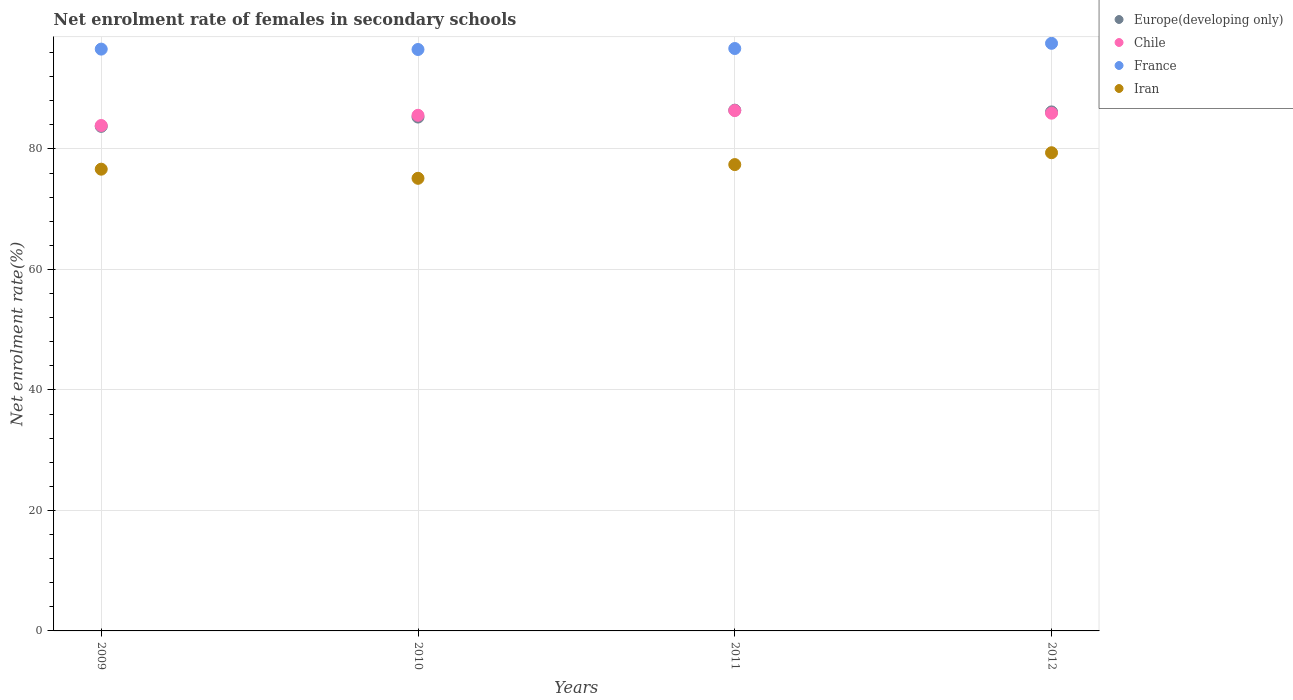What is the net enrolment rate of females in secondary schools in Iran in 2011?
Give a very brief answer. 77.4. Across all years, what is the maximum net enrolment rate of females in secondary schools in Iran?
Provide a short and direct response. 79.37. Across all years, what is the minimum net enrolment rate of females in secondary schools in Iran?
Your response must be concise. 75.12. In which year was the net enrolment rate of females in secondary schools in Iran minimum?
Provide a succinct answer. 2010. What is the total net enrolment rate of females in secondary schools in Iran in the graph?
Your answer should be very brief. 308.53. What is the difference between the net enrolment rate of females in secondary schools in Chile in 2011 and that in 2012?
Keep it short and to the point. 0.44. What is the difference between the net enrolment rate of females in secondary schools in Iran in 2012 and the net enrolment rate of females in secondary schools in Chile in 2009?
Offer a very short reply. -4.52. What is the average net enrolment rate of females in secondary schools in Chile per year?
Your answer should be very brief. 85.44. In the year 2012, what is the difference between the net enrolment rate of females in secondary schools in Chile and net enrolment rate of females in secondary schools in France?
Provide a succinct answer. -11.6. What is the ratio of the net enrolment rate of females in secondary schools in Chile in 2010 to that in 2012?
Make the answer very short. 1. What is the difference between the highest and the second highest net enrolment rate of females in secondary schools in France?
Provide a succinct answer. 0.86. What is the difference between the highest and the lowest net enrolment rate of females in secondary schools in France?
Ensure brevity in your answer.  1.02. Is the sum of the net enrolment rate of females in secondary schools in Chile in 2009 and 2012 greater than the maximum net enrolment rate of females in secondary schools in France across all years?
Offer a very short reply. Yes. Is it the case that in every year, the sum of the net enrolment rate of females in secondary schools in France and net enrolment rate of females in secondary schools in Chile  is greater than the net enrolment rate of females in secondary schools in Iran?
Keep it short and to the point. Yes. Is the net enrolment rate of females in secondary schools in Chile strictly greater than the net enrolment rate of females in secondary schools in France over the years?
Offer a terse response. No. Is the net enrolment rate of females in secondary schools in France strictly less than the net enrolment rate of females in secondary schools in Iran over the years?
Your answer should be compact. No. What is the difference between two consecutive major ticks on the Y-axis?
Your answer should be very brief. 20. Are the values on the major ticks of Y-axis written in scientific E-notation?
Give a very brief answer. No. Does the graph contain any zero values?
Provide a short and direct response. No. How many legend labels are there?
Provide a succinct answer. 4. How are the legend labels stacked?
Offer a very short reply. Vertical. What is the title of the graph?
Keep it short and to the point. Net enrolment rate of females in secondary schools. Does "Latvia" appear as one of the legend labels in the graph?
Provide a short and direct response. No. What is the label or title of the X-axis?
Offer a very short reply. Years. What is the label or title of the Y-axis?
Your answer should be compact. Net enrolment rate(%). What is the Net enrolment rate(%) in Europe(developing only) in 2009?
Provide a succinct answer. 83.75. What is the Net enrolment rate(%) in Chile in 2009?
Offer a terse response. 83.89. What is the Net enrolment rate(%) of France in 2009?
Provide a short and direct response. 96.57. What is the Net enrolment rate(%) in Iran in 2009?
Provide a succinct answer. 76.64. What is the Net enrolment rate(%) in Europe(developing only) in 2010?
Give a very brief answer. 85.29. What is the Net enrolment rate(%) in Chile in 2010?
Your answer should be compact. 85.58. What is the Net enrolment rate(%) of France in 2010?
Ensure brevity in your answer.  96.51. What is the Net enrolment rate(%) in Iran in 2010?
Offer a very short reply. 75.12. What is the Net enrolment rate(%) of Europe(developing only) in 2011?
Your answer should be compact. 86.43. What is the Net enrolment rate(%) of Chile in 2011?
Your answer should be very brief. 86.37. What is the Net enrolment rate(%) of France in 2011?
Offer a very short reply. 96.67. What is the Net enrolment rate(%) of Iran in 2011?
Give a very brief answer. 77.4. What is the Net enrolment rate(%) in Europe(developing only) in 2012?
Make the answer very short. 86.14. What is the Net enrolment rate(%) of Chile in 2012?
Keep it short and to the point. 85.93. What is the Net enrolment rate(%) in France in 2012?
Your response must be concise. 97.53. What is the Net enrolment rate(%) of Iran in 2012?
Provide a succinct answer. 79.37. Across all years, what is the maximum Net enrolment rate(%) in Europe(developing only)?
Offer a terse response. 86.43. Across all years, what is the maximum Net enrolment rate(%) of Chile?
Your response must be concise. 86.37. Across all years, what is the maximum Net enrolment rate(%) of France?
Your answer should be very brief. 97.53. Across all years, what is the maximum Net enrolment rate(%) of Iran?
Make the answer very short. 79.37. Across all years, what is the minimum Net enrolment rate(%) of Europe(developing only)?
Ensure brevity in your answer.  83.75. Across all years, what is the minimum Net enrolment rate(%) of Chile?
Ensure brevity in your answer.  83.89. Across all years, what is the minimum Net enrolment rate(%) in France?
Make the answer very short. 96.51. Across all years, what is the minimum Net enrolment rate(%) in Iran?
Give a very brief answer. 75.12. What is the total Net enrolment rate(%) in Europe(developing only) in the graph?
Keep it short and to the point. 341.61. What is the total Net enrolment rate(%) of Chile in the graph?
Your answer should be very brief. 341.77. What is the total Net enrolment rate(%) in France in the graph?
Give a very brief answer. 387.27. What is the total Net enrolment rate(%) of Iran in the graph?
Make the answer very short. 308.53. What is the difference between the Net enrolment rate(%) in Europe(developing only) in 2009 and that in 2010?
Keep it short and to the point. -1.54. What is the difference between the Net enrolment rate(%) in Chile in 2009 and that in 2010?
Your answer should be compact. -1.69. What is the difference between the Net enrolment rate(%) in France in 2009 and that in 2010?
Provide a short and direct response. 0.06. What is the difference between the Net enrolment rate(%) in Iran in 2009 and that in 2010?
Provide a succinct answer. 1.51. What is the difference between the Net enrolment rate(%) of Europe(developing only) in 2009 and that in 2011?
Provide a succinct answer. -2.69. What is the difference between the Net enrolment rate(%) in Chile in 2009 and that in 2011?
Offer a very short reply. -2.48. What is the difference between the Net enrolment rate(%) in France in 2009 and that in 2011?
Your answer should be very brief. -0.1. What is the difference between the Net enrolment rate(%) in Iran in 2009 and that in 2011?
Give a very brief answer. -0.76. What is the difference between the Net enrolment rate(%) of Europe(developing only) in 2009 and that in 2012?
Your response must be concise. -2.4. What is the difference between the Net enrolment rate(%) in Chile in 2009 and that in 2012?
Keep it short and to the point. -2.04. What is the difference between the Net enrolment rate(%) of France in 2009 and that in 2012?
Ensure brevity in your answer.  -0.96. What is the difference between the Net enrolment rate(%) in Iran in 2009 and that in 2012?
Offer a terse response. -2.73. What is the difference between the Net enrolment rate(%) in Europe(developing only) in 2010 and that in 2011?
Your response must be concise. -1.14. What is the difference between the Net enrolment rate(%) in Chile in 2010 and that in 2011?
Ensure brevity in your answer.  -0.78. What is the difference between the Net enrolment rate(%) of France in 2010 and that in 2011?
Provide a succinct answer. -0.16. What is the difference between the Net enrolment rate(%) of Iran in 2010 and that in 2011?
Your answer should be very brief. -2.28. What is the difference between the Net enrolment rate(%) in Europe(developing only) in 2010 and that in 2012?
Your answer should be very brief. -0.85. What is the difference between the Net enrolment rate(%) of Chile in 2010 and that in 2012?
Ensure brevity in your answer.  -0.35. What is the difference between the Net enrolment rate(%) of France in 2010 and that in 2012?
Provide a succinct answer. -1.02. What is the difference between the Net enrolment rate(%) in Iran in 2010 and that in 2012?
Your answer should be compact. -4.24. What is the difference between the Net enrolment rate(%) of Europe(developing only) in 2011 and that in 2012?
Offer a terse response. 0.29. What is the difference between the Net enrolment rate(%) in Chile in 2011 and that in 2012?
Offer a very short reply. 0.44. What is the difference between the Net enrolment rate(%) in France in 2011 and that in 2012?
Your response must be concise. -0.86. What is the difference between the Net enrolment rate(%) of Iran in 2011 and that in 2012?
Your answer should be compact. -1.97. What is the difference between the Net enrolment rate(%) in Europe(developing only) in 2009 and the Net enrolment rate(%) in Chile in 2010?
Make the answer very short. -1.84. What is the difference between the Net enrolment rate(%) in Europe(developing only) in 2009 and the Net enrolment rate(%) in France in 2010?
Your response must be concise. -12.76. What is the difference between the Net enrolment rate(%) in Europe(developing only) in 2009 and the Net enrolment rate(%) in Iran in 2010?
Provide a succinct answer. 8.62. What is the difference between the Net enrolment rate(%) of Chile in 2009 and the Net enrolment rate(%) of France in 2010?
Give a very brief answer. -12.61. What is the difference between the Net enrolment rate(%) of Chile in 2009 and the Net enrolment rate(%) of Iran in 2010?
Your answer should be compact. 8.77. What is the difference between the Net enrolment rate(%) in France in 2009 and the Net enrolment rate(%) in Iran in 2010?
Your answer should be very brief. 21.44. What is the difference between the Net enrolment rate(%) in Europe(developing only) in 2009 and the Net enrolment rate(%) in Chile in 2011?
Give a very brief answer. -2.62. What is the difference between the Net enrolment rate(%) of Europe(developing only) in 2009 and the Net enrolment rate(%) of France in 2011?
Offer a terse response. -12.92. What is the difference between the Net enrolment rate(%) of Europe(developing only) in 2009 and the Net enrolment rate(%) of Iran in 2011?
Your answer should be very brief. 6.34. What is the difference between the Net enrolment rate(%) of Chile in 2009 and the Net enrolment rate(%) of France in 2011?
Ensure brevity in your answer.  -12.78. What is the difference between the Net enrolment rate(%) of Chile in 2009 and the Net enrolment rate(%) of Iran in 2011?
Provide a succinct answer. 6.49. What is the difference between the Net enrolment rate(%) in France in 2009 and the Net enrolment rate(%) in Iran in 2011?
Give a very brief answer. 19.17. What is the difference between the Net enrolment rate(%) of Europe(developing only) in 2009 and the Net enrolment rate(%) of Chile in 2012?
Provide a succinct answer. -2.18. What is the difference between the Net enrolment rate(%) in Europe(developing only) in 2009 and the Net enrolment rate(%) in France in 2012?
Give a very brief answer. -13.78. What is the difference between the Net enrolment rate(%) in Europe(developing only) in 2009 and the Net enrolment rate(%) in Iran in 2012?
Keep it short and to the point. 4.38. What is the difference between the Net enrolment rate(%) of Chile in 2009 and the Net enrolment rate(%) of France in 2012?
Your answer should be compact. -13.64. What is the difference between the Net enrolment rate(%) of Chile in 2009 and the Net enrolment rate(%) of Iran in 2012?
Offer a terse response. 4.52. What is the difference between the Net enrolment rate(%) in France in 2009 and the Net enrolment rate(%) in Iran in 2012?
Provide a short and direct response. 17.2. What is the difference between the Net enrolment rate(%) in Europe(developing only) in 2010 and the Net enrolment rate(%) in Chile in 2011?
Keep it short and to the point. -1.08. What is the difference between the Net enrolment rate(%) in Europe(developing only) in 2010 and the Net enrolment rate(%) in France in 2011?
Keep it short and to the point. -11.38. What is the difference between the Net enrolment rate(%) in Europe(developing only) in 2010 and the Net enrolment rate(%) in Iran in 2011?
Your answer should be very brief. 7.89. What is the difference between the Net enrolment rate(%) of Chile in 2010 and the Net enrolment rate(%) of France in 2011?
Your response must be concise. -11.08. What is the difference between the Net enrolment rate(%) of Chile in 2010 and the Net enrolment rate(%) of Iran in 2011?
Your answer should be compact. 8.18. What is the difference between the Net enrolment rate(%) of France in 2010 and the Net enrolment rate(%) of Iran in 2011?
Your response must be concise. 19.1. What is the difference between the Net enrolment rate(%) in Europe(developing only) in 2010 and the Net enrolment rate(%) in Chile in 2012?
Ensure brevity in your answer.  -0.64. What is the difference between the Net enrolment rate(%) of Europe(developing only) in 2010 and the Net enrolment rate(%) of France in 2012?
Give a very brief answer. -12.24. What is the difference between the Net enrolment rate(%) of Europe(developing only) in 2010 and the Net enrolment rate(%) of Iran in 2012?
Provide a succinct answer. 5.92. What is the difference between the Net enrolment rate(%) of Chile in 2010 and the Net enrolment rate(%) of France in 2012?
Your answer should be very brief. -11.95. What is the difference between the Net enrolment rate(%) of Chile in 2010 and the Net enrolment rate(%) of Iran in 2012?
Your response must be concise. 6.21. What is the difference between the Net enrolment rate(%) of France in 2010 and the Net enrolment rate(%) of Iran in 2012?
Ensure brevity in your answer.  17.14. What is the difference between the Net enrolment rate(%) of Europe(developing only) in 2011 and the Net enrolment rate(%) of Chile in 2012?
Offer a terse response. 0.5. What is the difference between the Net enrolment rate(%) of Europe(developing only) in 2011 and the Net enrolment rate(%) of France in 2012?
Offer a very short reply. -11.1. What is the difference between the Net enrolment rate(%) in Europe(developing only) in 2011 and the Net enrolment rate(%) in Iran in 2012?
Provide a short and direct response. 7.06. What is the difference between the Net enrolment rate(%) in Chile in 2011 and the Net enrolment rate(%) in France in 2012?
Ensure brevity in your answer.  -11.16. What is the difference between the Net enrolment rate(%) in Chile in 2011 and the Net enrolment rate(%) in Iran in 2012?
Provide a short and direct response. 7. What is the difference between the Net enrolment rate(%) of France in 2011 and the Net enrolment rate(%) of Iran in 2012?
Offer a very short reply. 17.3. What is the average Net enrolment rate(%) of Europe(developing only) per year?
Provide a succinct answer. 85.4. What is the average Net enrolment rate(%) of Chile per year?
Make the answer very short. 85.44. What is the average Net enrolment rate(%) in France per year?
Your response must be concise. 96.82. What is the average Net enrolment rate(%) in Iran per year?
Offer a terse response. 77.13. In the year 2009, what is the difference between the Net enrolment rate(%) of Europe(developing only) and Net enrolment rate(%) of Chile?
Your answer should be compact. -0.14. In the year 2009, what is the difference between the Net enrolment rate(%) in Europe(developing only) and Net enrolment rate(%) in France?
Keep it short and to the point. -12.82. In the year 2009, what is the difference between the Net enrolment rate(%) in Europe(developing only) and Net enrolment rate(%) in Iran?
Offer a terse response. 7.11. In the year 2009, what is the difference between the Net enrolment rate(%) in Chile and Net enrolment rate(%) in France?
Offer a very short reply. -12.68. In the year 2009, what is the difference between the Net enrolment rate(%) in Chile and Net enrolment rate(%) in Iran?
Ensure brevity in your answer.  7.25. In the year 2009, what is the difference between the Net enrolment rate(%) in France and Net enrolment rate(%) in Iran?
Keep it short and to the point. 19.93. In the year 2010, what is the difference between the Net enrolment rate(%) in Europe(developing only) and Net enrolment rate(%) in Chile?
Offer a terse response. -0.29. In the year 2010, what is the difference between the Net enrolment rate(%) in Europe(developing only) and Net enrolment rate(%) in France?
Provide a succinct answer. -11.21. In the year 2010, what is the difference between the Net enrolment rate(%) in Europe(developing only) and Net enrolment rate(%) in Iran?
Your response must be concise. 10.17. In the year 2010, what is the difference between the Net enrolment rate(%) in Chile and Net enrolment rate(%) in France?
Your response must be concise. -10.92. In the year 2010, what is the difference between the Net enrolment rate(%) in Chile and Net enrolment rate(%) in Iran?
Make the answer very short. 10.46. In the year 2010, what is the difference between the Net enrolment rate(%) of France and Net enrolment rate(%) of Iran?
Offer a terse response. 21.38. In the year 2011, what is the difference between the Net enrolment rate(%) of Europe(developing only) and Net enrolment rate(%) of Chile?
Keep it short and to the point. 0.07. In the year 2011, what is the difference between the Net enrolment rate(%) in Europe(developing only) and Net enrolment rate(%) in France?
Offer a terse response. -10.23. In the year 2011, what is the difference between the Net enrolment rate(%) of Europe(developing only) and Net enrolment rate(%) of Iran?
Give a very brief answer. 9.03. In the year 2011, what is the difference between the Net enrolment rate(%) in Chile and Net enrolment rate(%) in France?
Ensure brevity in your answer.  -10.3. In the year 2011, what is the difference between the Net enrolment rate(%) of Chile and Net enrolment rate(%) of Iran?
Your answer should be compact. 8.97. In the year 2011, what is the difference between the Net enrolment rate(%) of France and Net enrolment rate(%) of Iran?
Give a very brief answer. 19.26. In the year 2012, what is the difference between the Net enrolment rate(%) in Europe(developing only) and Net enrolment rate(%) in Chile?
Offer a terse response. 0.21. In the year 2012, what is the difference between the Net enrolment rate(%) of Europe(developing only) and Net enrolment rate(%) of France?
Your answer should be very brief. -11.38. In the year 2012, what is the difference between the Net enrolment rate(%) in Europe(developing only) and Net enrolment rate(%) in Iran?
Give a very brief answer. 6.78. In the year 2012, what is the difference between the Net enrolment rate(%) of Chile and Net enrolment rate(%) of France?
Give a very brief answer. -11.6. In the year 2012, what is the difference between the Net enrolment rate(%) of Chile and Net enrolment rate(%) of Iran?
Ensure brevity in your answer.  6.56. In the year 2012, what is the difference between the Net enrolment rate(%) in France and Net enrolment rate(%) in Iran?
Offer a very short reply. 18.16. What is the ratio of the Net enrolment rate(%) of Europe(developing only) in 2009 to that in 2010?
Ensure brevity in your answer.  0.98. What is the ratio of the Net enrolment rate(%) of Chile in 2009 to that in 2010?
Your answer should be compact. 0.98. What is the ratio of the Net enrolment rate(%) in France in 2009 to that in 2010?
Provide a short and direct response. 1. What is the ratio of the Net enrolment rate(%) in Iran in 2009 to that in 2010?
Your answer should be very brief. 1.02. What is the ratio of the Net enrolment rate(%) in Europe(developing only) in 2009 to that in 2011?
Keep it short and to the point. 0.97. What is the ratio of the Net enrolment rate(%) of Chile in 2009 to that in 2011?
Your answer should be very brief. 0.97. What is the ratio of the Net enrolment rate(%) in Iran in 2009 to that in 2011?
Your answer should be compact. 0.99. What is the ratio of the Net enrolment rate(%) of Europe(developing only) in 2009 to that in 2012?
Give a very brief answer. 0.97. What is the ratio of the Net enrolment rate(%) in Chile in 2009 to that in 2012?
Give a very brief answer. 0.98. What is the ratio of the Net enrolment rate(%) of France in 2009 to that in 2012?
Offer a terse response. 0.99. What is the ratio of the Net enrolment rate(%) of Iran in 2009 to that in 2012?
Your answer should be very brief. 0.97. What is the ratio of the Net enrolment rate(%) in Europe(developing only) in 2010 to that in 2011?
Your answer should be compact. 0.99. What is the ratio of the Net enrolment rate(%) in Chile in 2010 to that in 2011?
Your response must be concise. 0.99. What is the ratio of the Net enrolment rate(%) of France in 2010 to that in 2011?
Provide a succinct answer. 1. What is the ratio of the Net enrolment rate(%) of Iran in 2010 to that in 2011?
Provide a short and direct response. 0.97. What is the ratio of the Net enrolment rate(%) in Chile in 2010 to that in 2012?
Your response must be concise. 1. What is the ratio of the Net enrolment rate(%) of Iran in 2010 to that in 2012?
Provide a succinct answer. 0.95. What is the ratio of the Net enrolment rate(%) of Europe(developing only) in 2011 to that in 2012?
Offer a very short reply. 1. What is the ratio of the Net enrolment rate(%) in Chile in 2011 to that in 2012?
Offer a very short reply. 1.01. What is the ratio of the Net enrolment rate(%) of France in 2011 to that in 2012?
Your answer should be very brief. 0.99. What is the ratio of the Net enrolment rate(%) of Iran in 2011 to that in 2012?
Offer a terse response. 0.98. What is the difference between the highest and the second highest Net enrolment rate(%) of Europe(developing only)?
Offer a very short reply. 0.29. What is the difference between the highest and the second highest Net enrolment rate(%) in Chile?
Offer a very short reply. 0.44. What is the difference between the highest and the second highest Net enrolment rate(%) of France?
Your answer should be compact. 0.86. What is the difference between the highest and the second highest Net enrolment rate(%) in Iran?
Give a very brief answer. 1.97. What is the difference between the highest and the lowest Net enrolment rate(%) of Europe(developing only)?
Offer a very short reply. 2.69. What is the difference between the highest and the lowest Net enrolment rate(%) in Chile?
Provide a short and direct response. 2.48. What is the difference between the highest and the lowest Net enrolment rate(%) in France?
Provide a succinct answer. 1.02. What is the difference between the highest and the lowest Net enrolment rate(%) in Iran?
Your response must be concise. 4.24. 